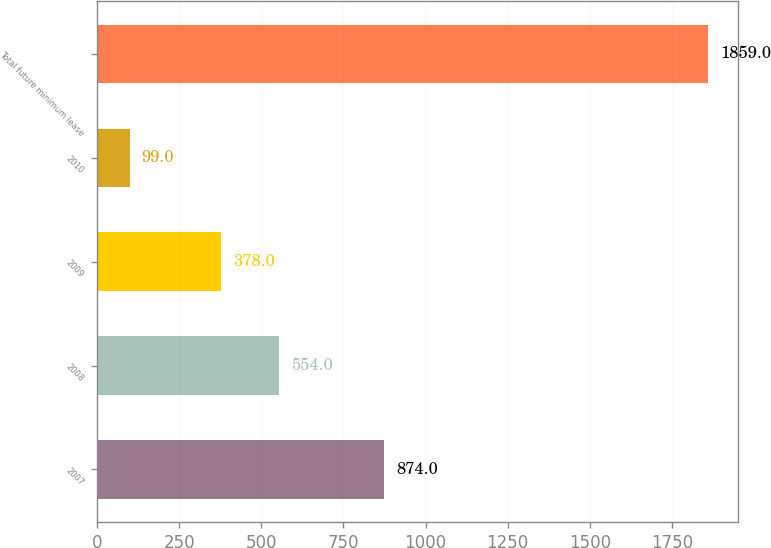Convert chart. <chart><loc_0><loc_0><loc_500><loc_500><bar_chart><fcel>2007<fcel>2008<fcel>2009<fcel>2010<fcel>Total future minimum lease<nl><fcel>874<fcel>554<fcel>378<fcel>99<fcel>1859<nl></chart> 